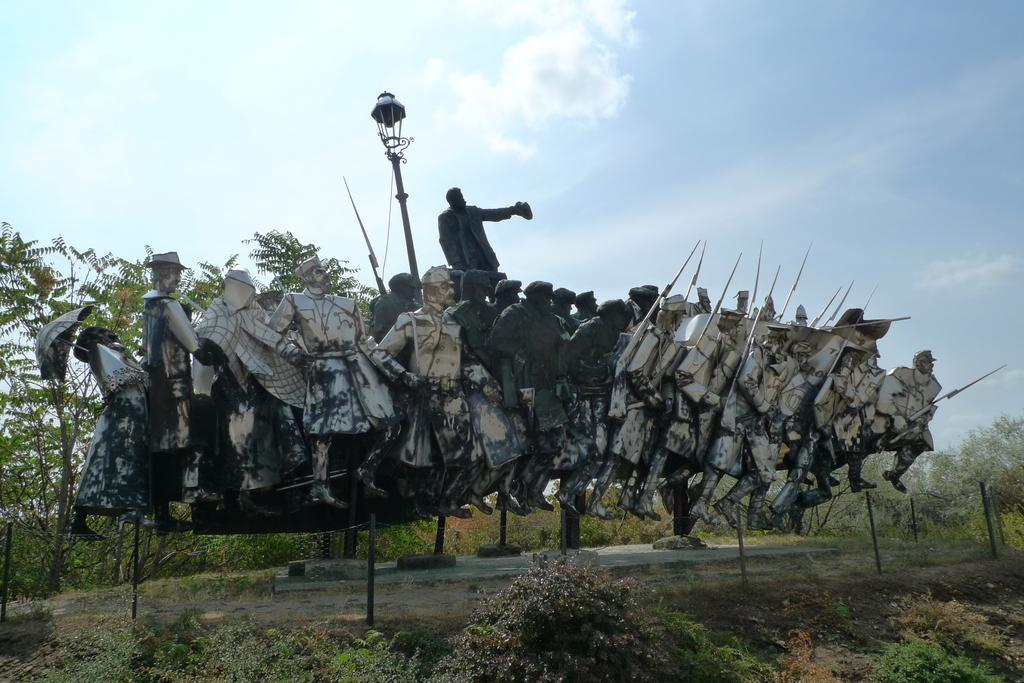Can you describe this image briefly? We can see sculptures of people and we can see plants and light on pole. Background we can see trees and sky. 